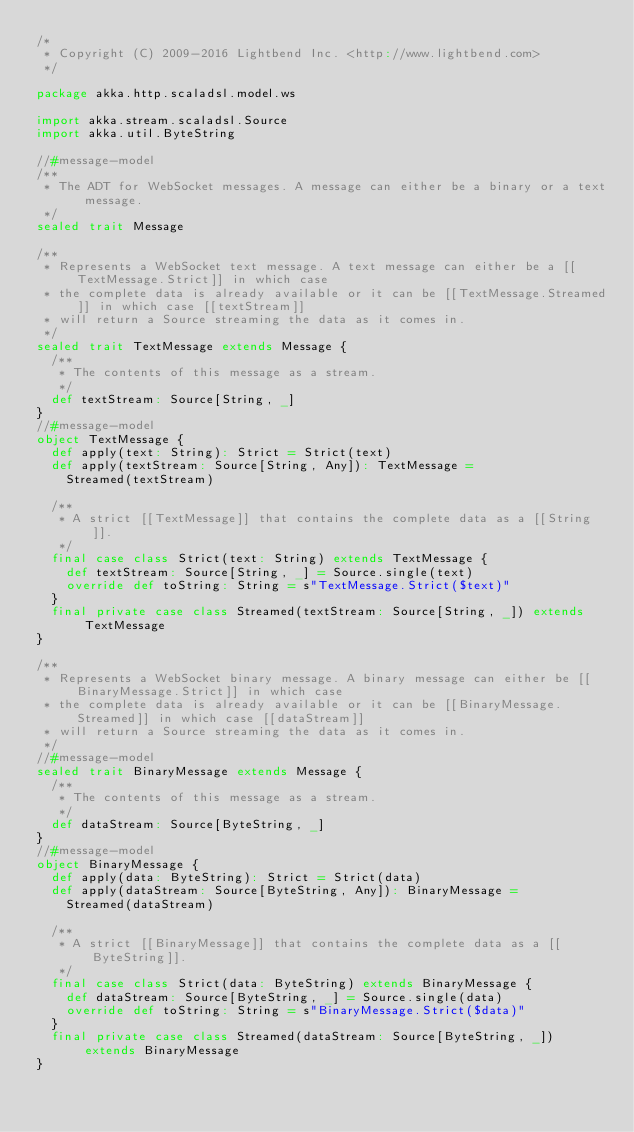Convert code to text. <code><loc_0><loc_0><loc_500><loc_500><_Scala_>/*
 * Copyright (C) 2009-2016 Lightbend Inc. <http://www.lightbend.com>
 */

package akka.http.scaladsl.model.ws

import akka.stream.scaladsl.Source
import akka.util.ByteString

//#message-model
/**
 * The ADT for WebSocket messages. A message can either be a binary or a text message.
 */
sealed trait Message

/**
 * Represents a WebSocket text message. A text message can either be a [[TextMessage.Strict]] in which case
 * the complete data is already available or it can be [[TextMessage.Streamed]] in which case [[textStream]]
 * will return a Source streaming the data as it comes in.
 */
sealed trait TextMessage extends Message {
  /**
   * The contents of this message as a stream.
   */
  def textStream: Source[String, _]
}
//#message-model
object TextMessage {
  def apply(text: String): Strict = Strict(text)
  def apply(textStream: Source[String, Any]): TextMessage =
    Streamed(textStream)

  /**
   * A strict [[TextMessage]] that contains the complete data as a [[String]].
   */
  final case class Strict(text: String) extends TextMessage {
    def textStream: Source[String, _] = Source.single(text)
    override def toString: String = s"TextMessage.Strict($text)"
  }
  final private case class Streamed(textStream: Source[String, _]) extends TextMessage
}

/**
 * Represents a WebSocket binary message. A binary message can either be [[BinaryMessage.Strict]] in which case
 * the complete data is already available or it can be [[BinaryMessage.Streamed]] in which case [[dataStream]]
 * will return a Source streaming the data as it comes in.
 */
//#message-model
sealed trait BinaryMessage extends Message {
  /**
   * The contents of this message as a stream.
   */
  def dataStream: Source[ByteString, _]
}
//#message-model
object BinaryMessage {
  def apply(data: ByteString): Strict = Strict(data)
  def apply(dataStream: Source[ByteString, Any]): BinaryMessage =
    Streamed(dataStream)

  /**
   * A strict [[BinaryMessage]] that contains the complete data as a [[ByteString]].
   */
  final case class Strict(data: ByteString) extends BinaryMessage {
    def dataStream: Source[ByteString, _] = Source.single(data)
    override def toString: String = s"BinaryMessage.Strict($data)"
  }
  final private case class Streamed(dataStream: Source[ByteString, _]) extends BinaryMessage
}</code> 